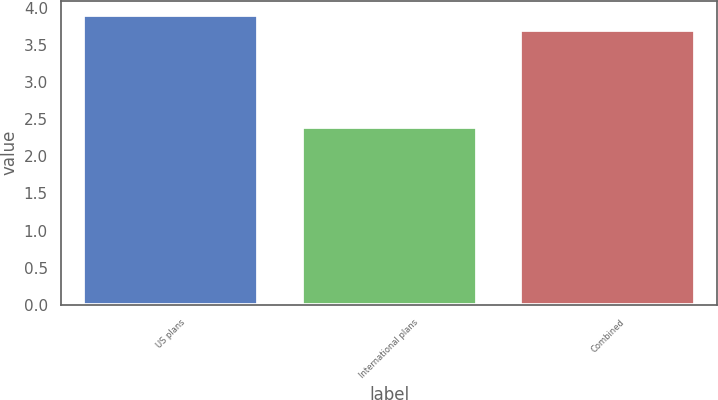<chart> <loc_0><loc_0><loc_500><loc_500><bar_chart><fcel>US plans<fcel>International plans<fcel>Combined<nl><fcel>3.9<fcel>2.4<fcel>3.7<nl></chart> 